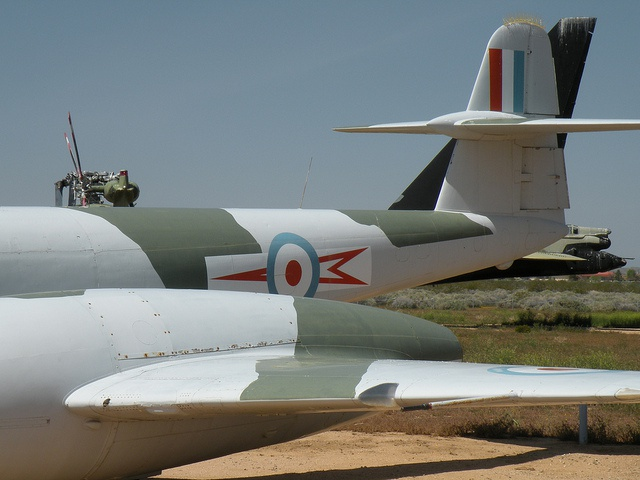Describe the objects in this image and their specific colors. I can see airplane in gray, lightgray, and darkgray tones, airplane in gray, darkgray, black, and lightgray tones, and airplane in gray, black, and darkgray tones in this image. 